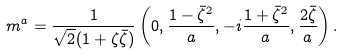<formula> <loc_0><loc_0><loc_500><loc_500>m ^ { a } = \frac { 1 } { \sqrt { 2 } ( 1 + \zeta \bar { \zeta } ) } \left ( 0 , \frac { 1 - \bar { \zeta } ^ { 2 } } { a } , - i \frac { 1 + \bar { \zeta } ^ { 2 } } { a } , \frac { 2 \bar { \zeta } } { a } \right ) .</formula> 